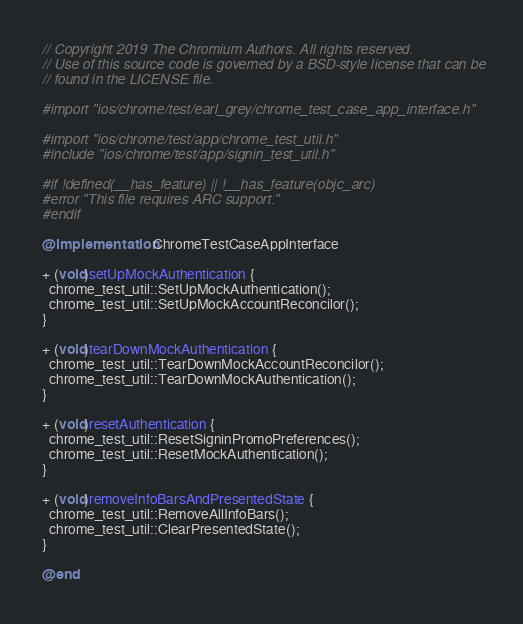Convert code to text. <code><loc_0><loc_0><loc_500><loc_500><_ObjectiveC_>// Copyright 2019 The Chromium Authors. All rights reserved.
// Use of this source code is governed by a BSD-style license that can be
// found in the LICENSE file.

#import "ios/chrome/test/earl_grey/chrome_test_case_app_interface.h"

#import "ios/chrome/test/app/chrome_test_util.h"
#include "ios/chrome/test/app/signin_test_util.h"

#if !defined(__has_feature) || !__has_feature(objc_arc)
#error "This file requires ARC support."
#endif

@implementation ChromeTestCaseAppInterface

+ (void)setUpMockAuthentication {
  chrome_test_util::SetUpMockAuthentication();
  chrome_test_util::SetUpMockAccountReconcilor();
}

+ (void)tearDownMockAuthentication {
  chrome_test_util::TearDownMockAccountReconcilor();
  chrome_test_util::TearDownMockAuthentication();
}

+ (void)resetAuthentication {
  chrome_test_util::ResetSigninPromoPreferences();
  chrome_test_util::ResetMockAuthentication();
}

+ (void)removeInfoBarsAndPresentedState {
  chrome_test_util::RemoveAllInfoBars();
  chrome_test_util::ClearPresentedState();
}

@end
</code> 